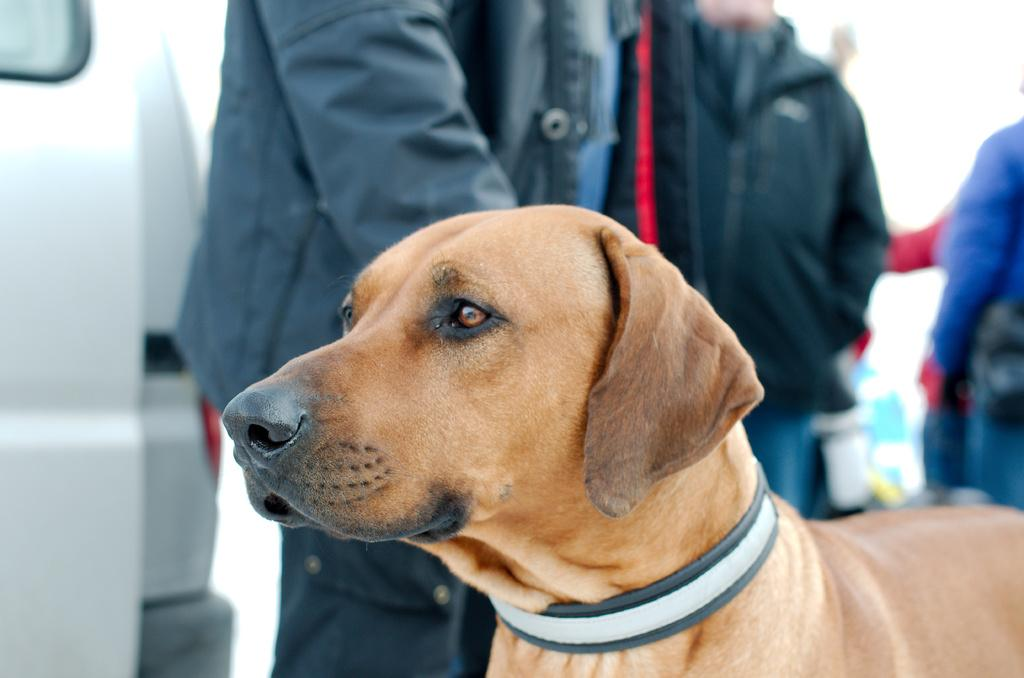What type of animal is in the image? There is a dog in the image. What else can be seen in the background of the image? There are people in the background of the image. What is located on the left side of the image? There appears to be a vehicle on the left side of the image. What type of fork can be seen in the image? There is no fork present in the image. 